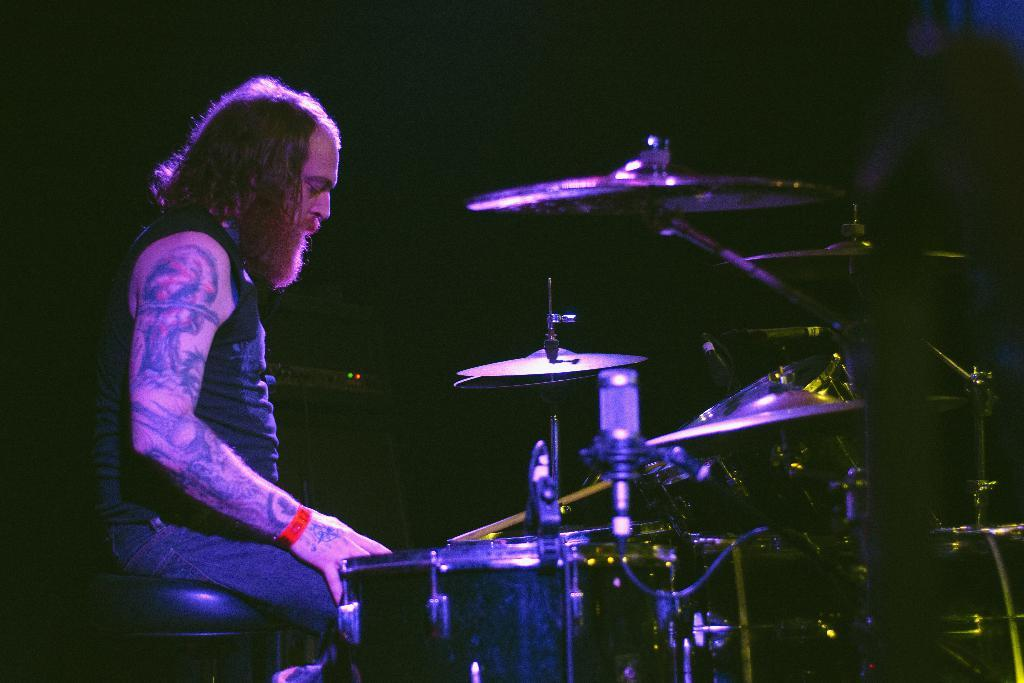What is the main subject of the image? The main subject of the image is a person. What is the person doing in the image? The person is playing a musical instrument in the image. Can you describe the background of the image? The background of the image is dark. Is the person's father playing a musical instrument with them in the image? There is no information about the person's father or any other person in the image, so it cannot be determined if they are playing a musical instrument together. 